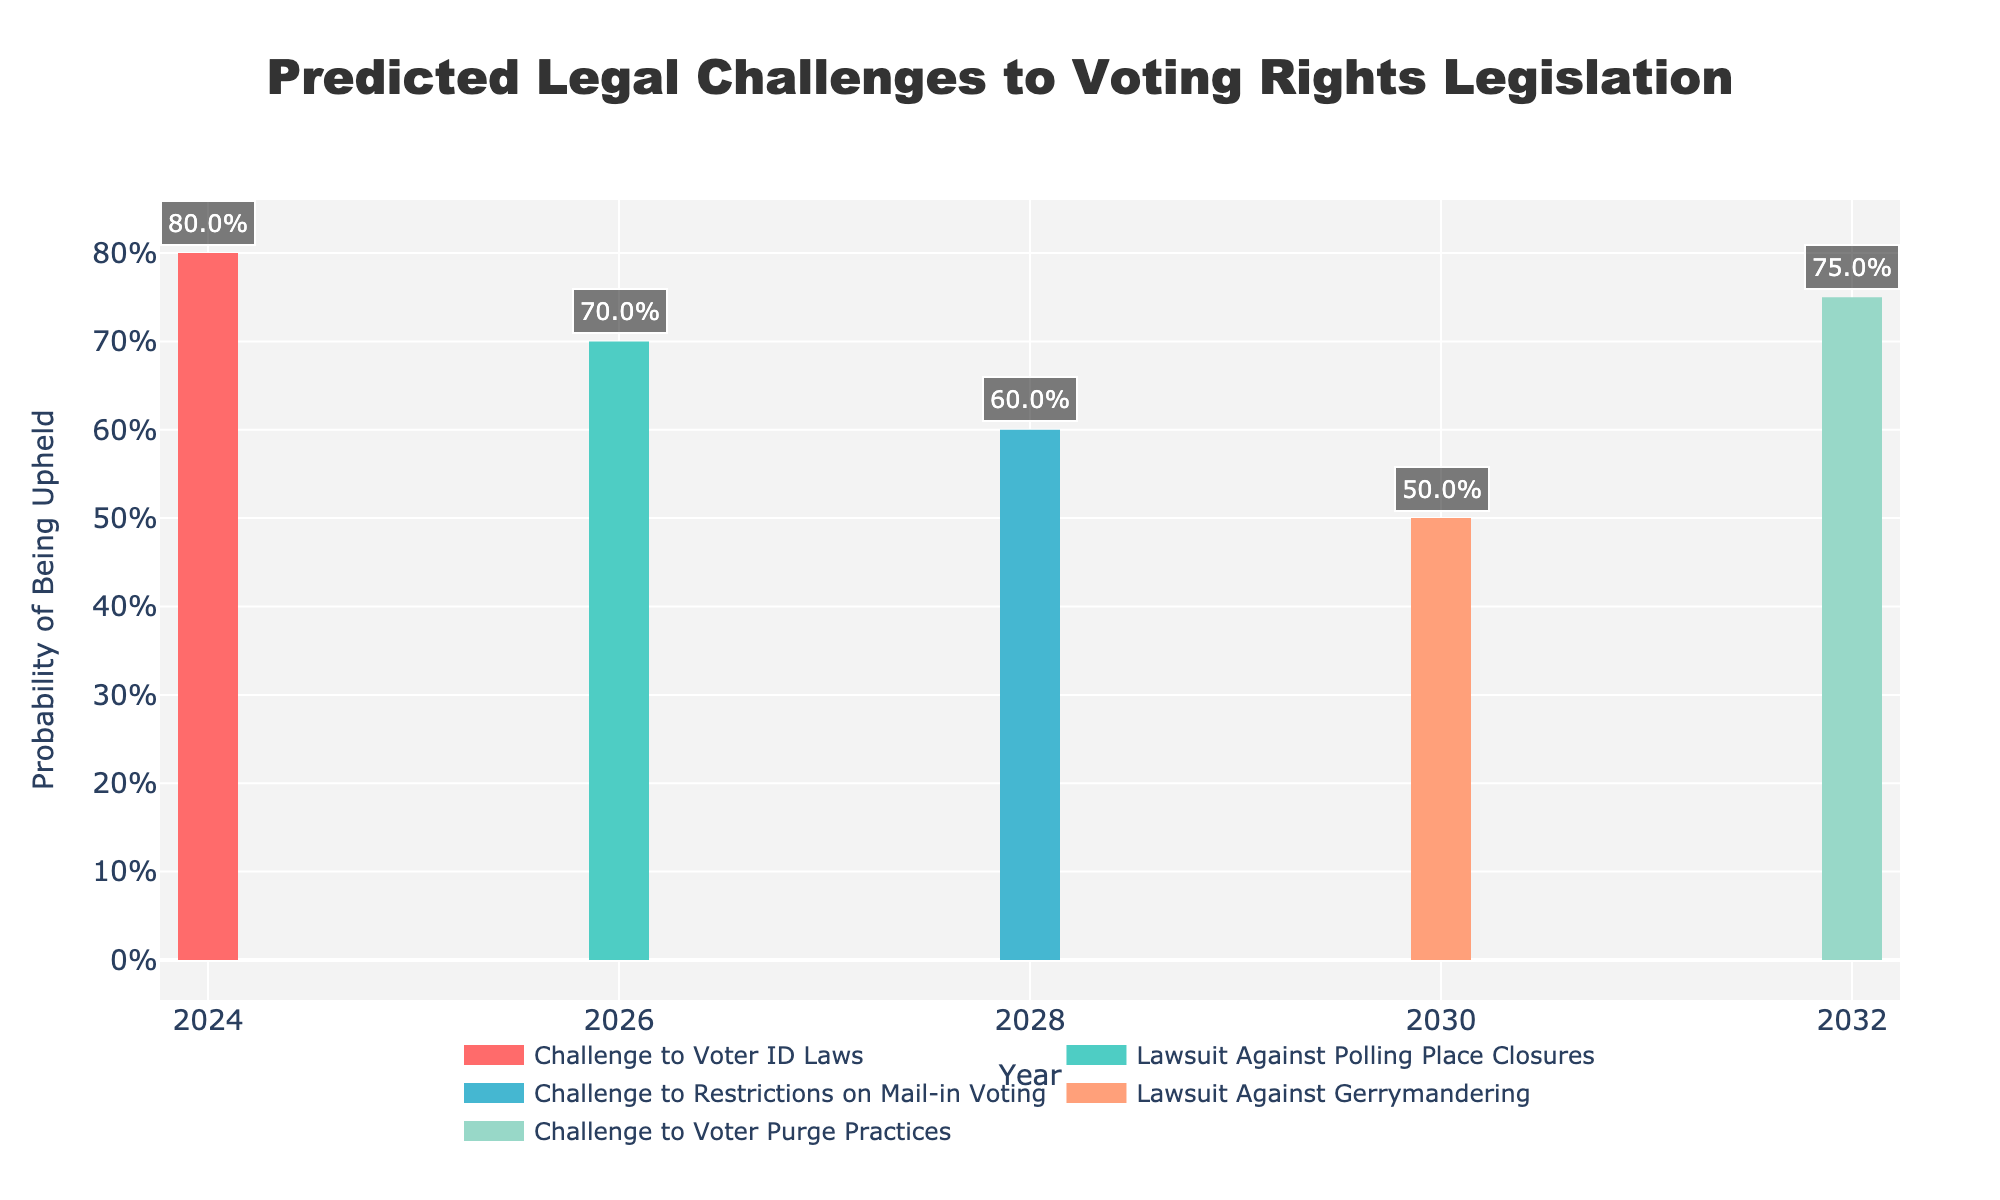What is the title of the figure? The title is found at the top part of the figure, displayed prominently.
Answer: Predicted Legal Challenges to Voting Rights Legislation What is the likelihood of the "Challenge to Voter ID Laws" being upheld in 2024? Look on the chart, find the scenario "Challenge to Voter ID Laws" at the year 2024, and read the probability value on the Y-axis where the colored line ends.
Answer: 80% How many different scenarios of legal challenges are depicted in the chart? Look at the legend or the different colored lines representing each scenario. Count these different lines or labels.
Answer: 5 Which year has an equal probability for both possible outcomes "Upheld" and "Struck Down"? On the X-axis, find the year where the line reaches the 0.5 or 50% mark on the Y-axis, which indicates equal probability.
Answer: 2030 Which scenario has the lowest likelihood of being upheld, and what is it? Compare the heights of the colored lines representing each scenario. The lowest line indicates the lowest likelihood.
Answer: Challenge to Restrictions on Mail-in Voting; 60% How much more likely is the "Challenge to Voter Purge Practices" to be upheld compared to "Lawsuit Against Gerrymandering" in their respective years? Subtract the percentage likelihood of "Lawsuit Against Gerrymandering" being upheld (2030) from that of "Challenge to Voter Purge Practices" (2032).
Answer: 25% more likely What are the predicted outcomes and their probabilities for the "Lawsuit Against Polling Place Closures" in 2026? Locate the "Lawsuit Against Polling Place Closures" scenario at the year 2026. Read the heights of both lines to determine the probabilities for both outcomes.
Answer: Upheld: 70%, Struck Down: 30% Which scenarios have a probability of being upheld that is higher than 60%? Identify the scenarios where the height of the corresponding line on the chart is above the 60% marker on the Y-axis.
Answer: Challenge to Voter ID Laws, Lawsuit Against Polling Place Closures, Challenge to Voter Purge Practices What is the average likelihood of legal challenges being upheld across all scenarios shown? Add all the probabilities for being upheld for each scenario, then divide by the number of scenarios. [(0.8 + 0.7 + 0.6 + 0.5 + 0.75) / 5] * 100%.
Answer: 67% 